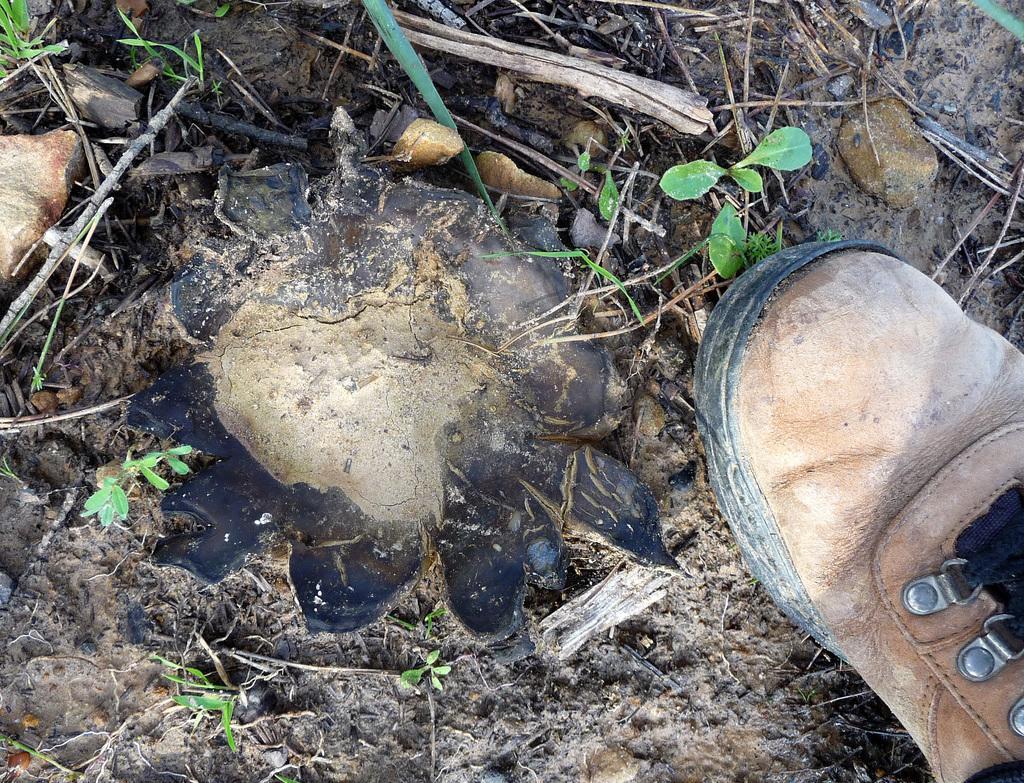Can you describe this image briefly? In this image we can see a shoe placed on the ground. 